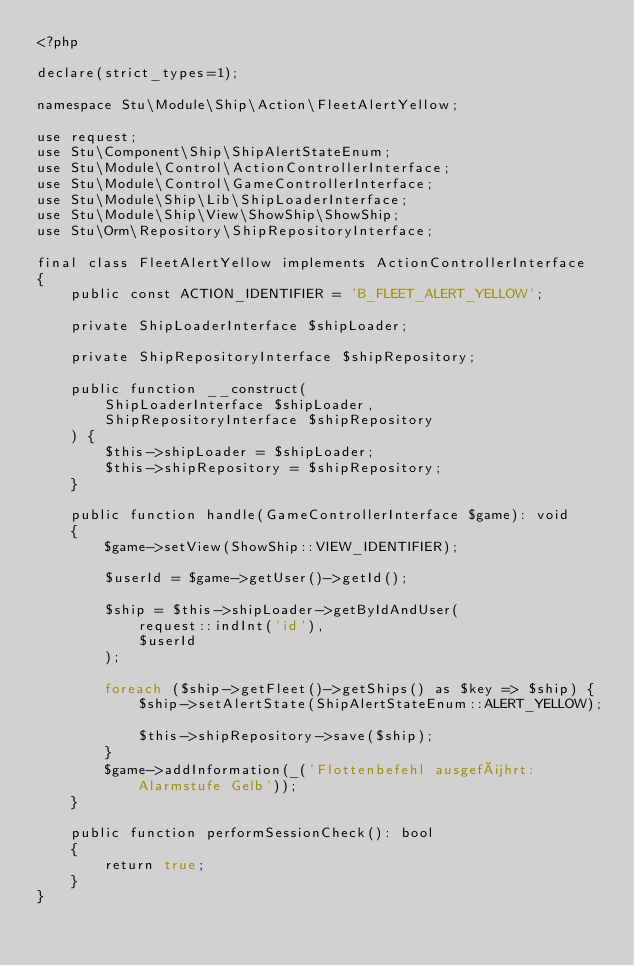<code> <loc_0><loc_0><loc_500><loc_500><_PHP_><?php

declare(strict_types=1);

namespace Stu\Module\Ship\Action\FleetAlertYellow;

use request;
use Stu\Component\Ship\ShipAlertStateEnum;
use Stu\Module\Control\ActionControllerInterface;
use Stu\Module\Control\GameControllerInterface;
use Stu\Module\Ship\Lib\ShipLoaderInterface;
use Stu\Module\Ship\View\ShowShip\ShowShip;
use Stu\Orm\Repository\ShipRepositoryInterface;

final class FleetAlertYellow implements ActionControllerInterface
{
    public const ACTION_IDENTIFIER = 'B_FLEET_ALERT_YELLOW';

    private ShipLoaderInterface $shipLoader;

    private ShipRepositoryInterface $shipRepository;

    public function __construct(
        ShipLoaderInterface $shipLoader,
        ShipRepositoryInterface $shipRepository
    ) {
        $this->shipLoader = $shipLoader;
        $this->shipRepository = $shipRepository;
    }

    public function handle(GameControllerInterface $game): void
    {
        $game->setView(ShowShip::VIEW_IDENTIFIER);

        $userId = $game->getUser()->getId();

        $ship = $this->shipLoader->getByIdAndUser(
            request::indInt('id'),
            $userId
        );

        foreach ($ship->getFleet()->getShips() as $key => $ship) {
            $ship->setAlertState(ShipAlertStateEnum::ALERT_YELLOW);

            $this->shipRepository->save($ship);
        }
        $game->addInformation(_('Flottenbefehl ausgeführt: Alarmstufe Gelb'));
    }

    public function performSessionCheck(): bool
    {
        return true;
    }
}
</code> 